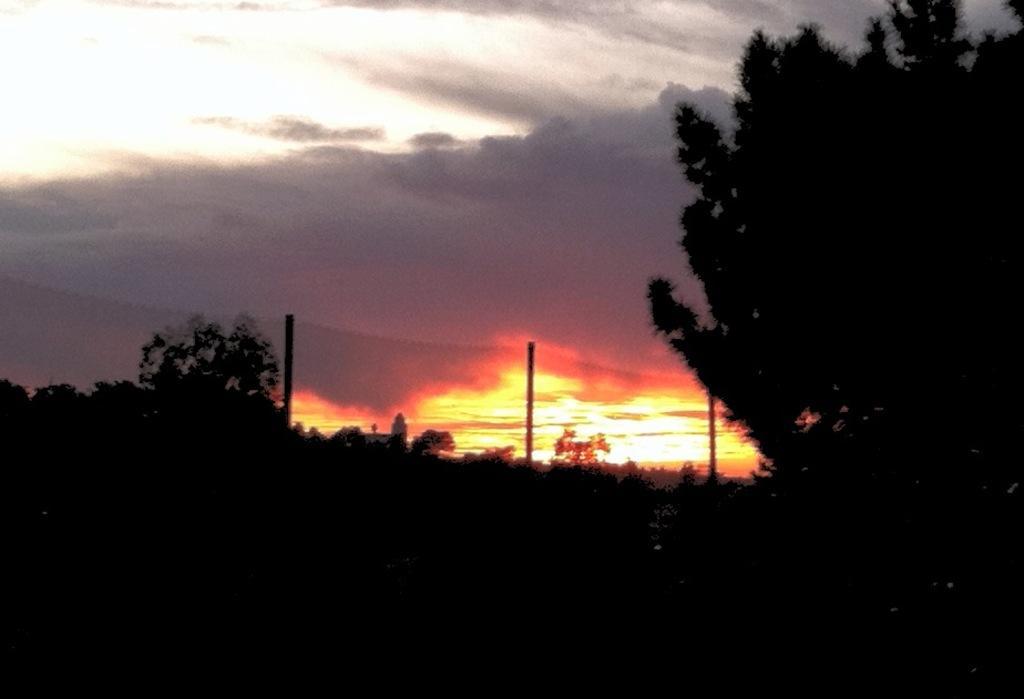Could you give a brief overview of what you see in this image? In this image we can see many trees. On the left there is a hill. We can also see the poles and at the top there is a cloudy sky. 